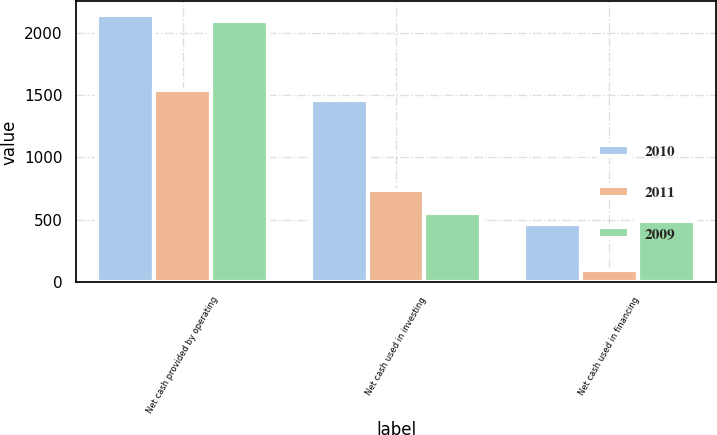Convert chart. <chart><loc_0><loc_0><loc_500><loc_500><stacked_bar_chart><ecel><fcel>Net cash provided by operating<fcel>Net cash used in investing<fcel>Net cash used in financing<nl><fcel>2010<fcel>2143<fcel>1458<fcel>464<nl><fcel>2011<fcel>1542<fcel>743<fcel>102<nl><fcel>2009<fcel>2095<fcel>552<fcel>491<nl></chart> 